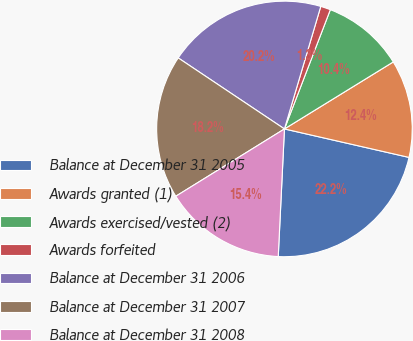Convert chart. <chart><loc_0><loc_0><loc_500><loc_500><pie_chart><fcel>Balance at December 31 2005<fcel>Awards granted (1)<fcel>Awards exercised/vested (2)<fcel>Awards forfeited<fcel>Balance at December 31 2006<fcel>Balance at December 31 2007<fcel>Balance at December 31 2008<nl><fcel>22.2%<fcel>12.36%<fcel>10.37%<fcel>1.26%<fcel>20.21%<fcel>18.21%<fcel>15.4%<nl></chart> 